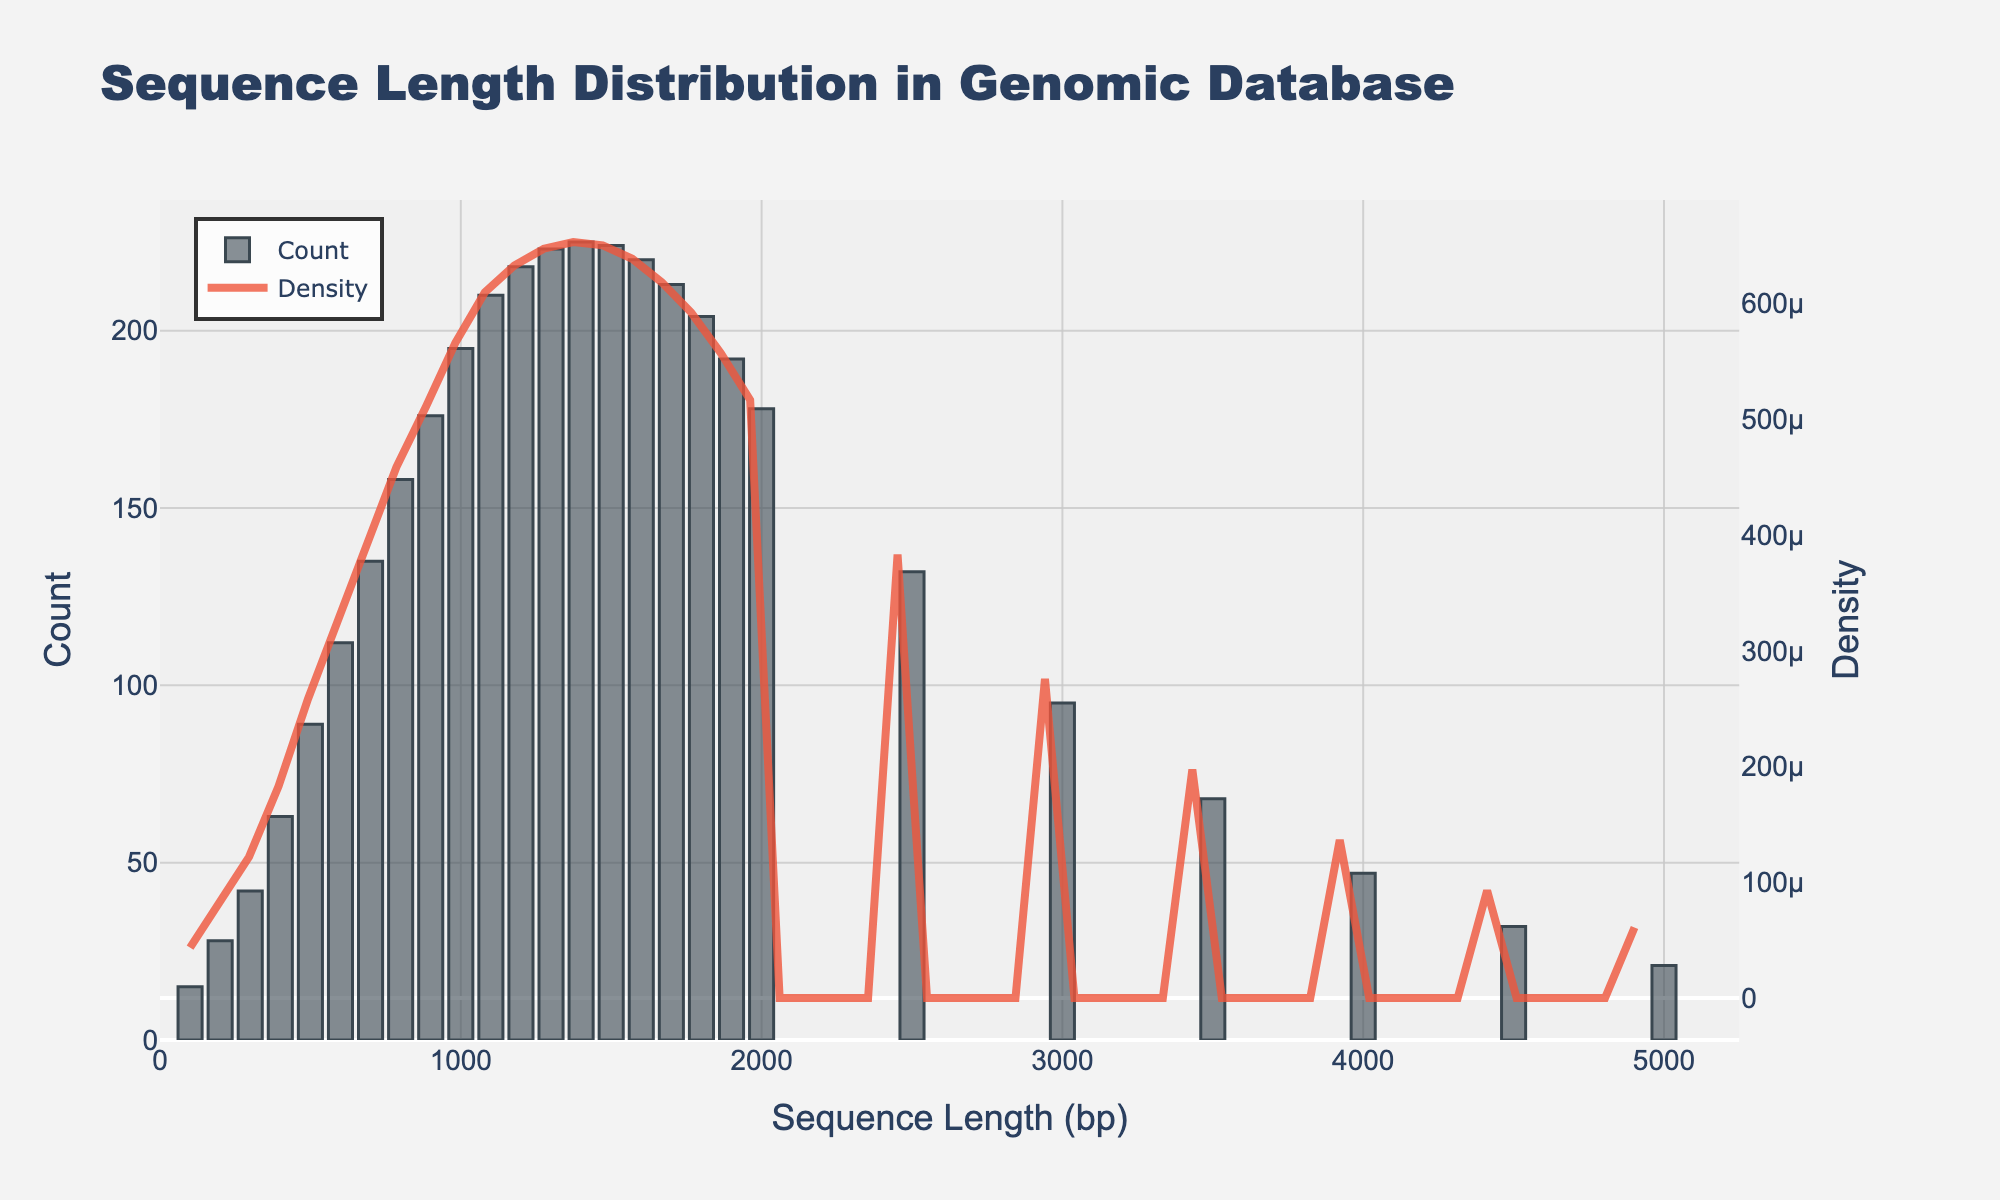What is the title of the figure? The title of the figure is the text at the top. By looking at the figure, we can see the title "Sequence Length Distribution in Genomic Database".
Answer: Sequence Length Distribution in Genomic Database How many bins are used in the histogram? The histogram bins can be determined by counting the bars. There are around 26 bins in the figure, corresponding to the different counts of sequence lengths.
Answer: 26 Which sequence length has the highest count? To find the sequence length with the highest count, observe the tallest bar in the histogram. It appears around the 1500 sequence length mark.
Answer: Around 1400-1500 How does the density at sequence length 2000 compare to the density at sequence length 1000? To compare densities at specific sequence lengths, look at the height of the KDE curve at those points. The density at sequence length 1000 is significantly higher than at 2000 as indicated by the height of the curve.
Answer: Density at 1000 is higher than at 2000 What is the range of sequence lengths covered by the histogram? The range is determined by identifying the smallest and largest sequence lengths on the x-axis. The x-axis ranges from 0 to about 5000.
Answer: 0 to 5000 What can be said about the overall trend of the sequence count as the sequence length increases? Observe the histogram bars as sequence length increases. Initially, there is an increase in count up to around 1400-1500, then it decreases steadily.
Answer: Increase initially, then decrease How does the count of sequence lengths at 800 compare with the count at 3000? Compare the heights of the bars at these sequence lengths. The count at 800 is significantly higher than at 3000.
Answer: Count at 800 is higher than at 3000 What sequence length corresponds to the peak of the density curve? To find the peak, look at the highest point of the KDE curve. The peak density appears around the same point (1400-1500) as the highest count.
Answer: Around 1400-1500 Is there any noticeable difference between the trends of the histogram and the KDE curve? Compare the shapes of the histogram and the KDE curve. While the histogram shows discrete counts with an increasing then decreasing trend, the KDE provides a smoothed version of this, confirming the same general trend.
Answer: Both show similar increasing and then decreasing trends What indications are there of any potential outliers in the sequence length distribution? Potential outliers can be identified by observing any significant bars standing alone at the extremes of the histogram. Sequence lengths at very high ranges (beyond 3000) have notably lower counts, indicating potential outliers.
Answer: Sequence lengths beyond 3000 